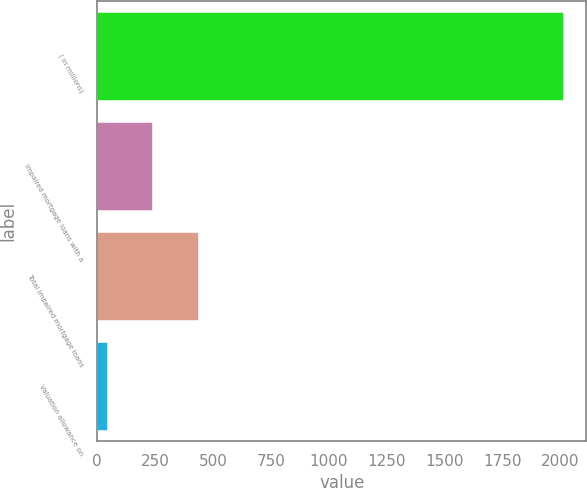Convert chart to OTSL. <chart><loc_0><loc_0><loc_500><loc_500><bar_chart><fcel>( in millions)<fcel>Impaired mortgage loans with a<fcel>Total impaired mortgage loans<fcel>Valuation allowance on<nl><fcel>2012<fcel>239<fcel>436<fcel>42<nl></chart> 